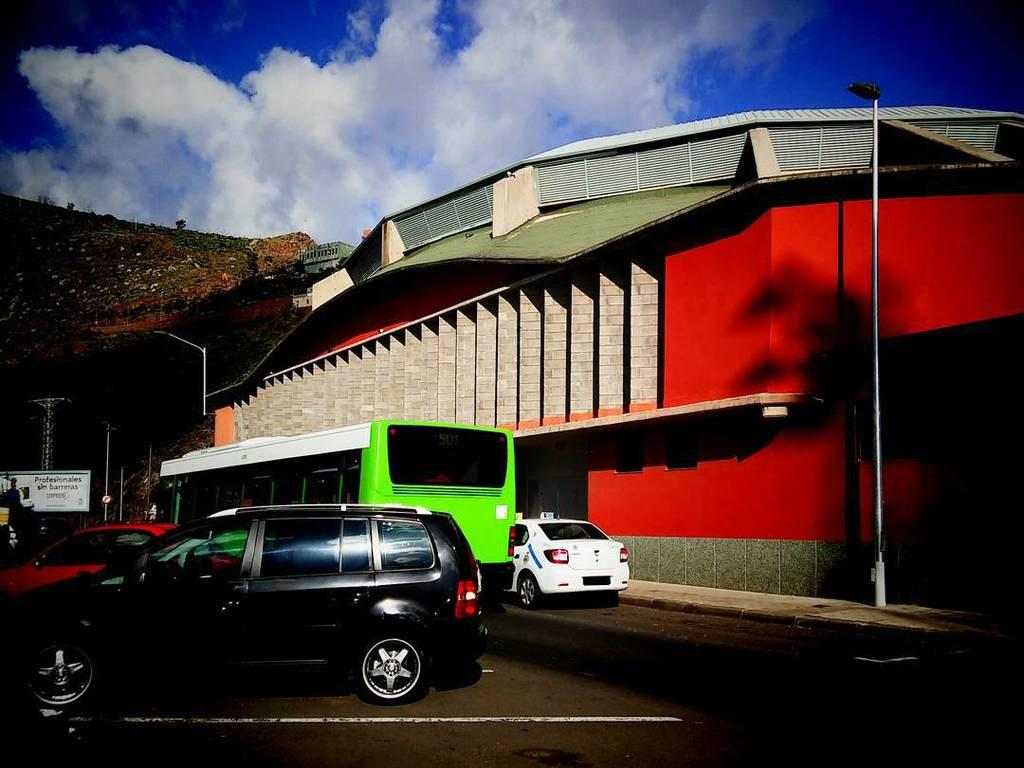What can be seen on the road in the image? There are many vehicles on the road in the image. What is the purpose of the white line on the road? The white line on the road is likely for traffic guidance or separation. What is the tall, cylindrical object in the image? There is a light pole in the image. What type of structure is visible in the image? There is a building in the image. What is the transparent barrier in the image? There is a window in the image. What is the condition of the sky in the image? The sky is cloudy in the image. How many robins are perched on the light pole in the image? There are no robins present in the image; it only features vehicles, a white line, a light pole, a building, a window, and a cloudy sky. 